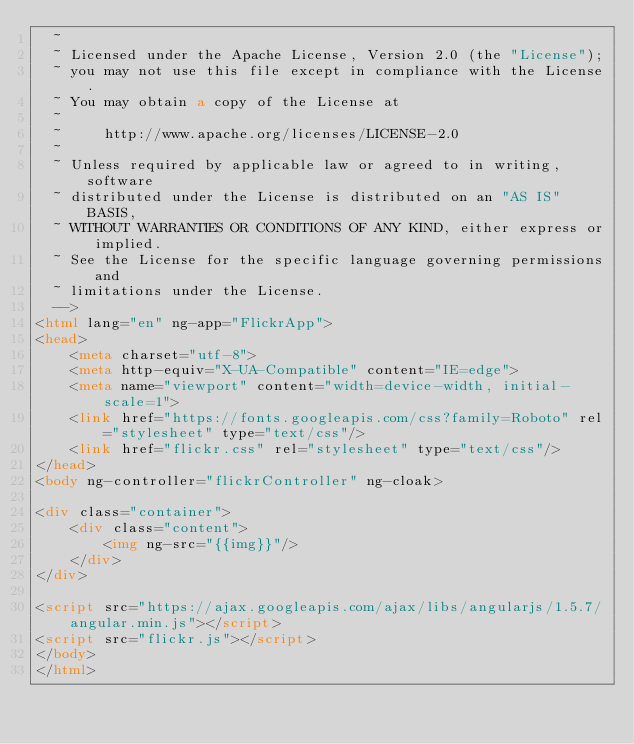Convert code to text. <code><loc_0><loc_0><loc_500><loc_500><_HTML_>  ~
  ~ Licensed under the Apache License, Version 2.0 (the "License");
  ~ you may not use this file except in compliance with the License.
  ~ You may obtain a copy of the License at
  ~
  ~     http://www.apache.org/licenses/LICENSE-2.0
  ~
  ~ Unless required by applicable law or agreed to in writing, software
  ~ distributed under the License is distributed on an "AS IS" BASIS,
  ~ WITHOUT WARRANTIES OR CONDITIONS OF ANY KIND, either express or implied.
  ~ See the License for the specific language governing permissions and
  ~ limitations under the License.
  -->
<html lang="en" ng-app="FlickrApp">
<head>
    <meta charset="utf-8">
    <meta http-equiv="X-UA-Compatible" content="IE=edge">
    <meta name="viewport" content="width=device-width, initial-scale=1">
    <link href="https://fonts.googleapis.com/css?family=Roboto" rel="stylesheet" type="text/css"/>
    <link href="flickr.css" rel="stylesheet" type="text/css"/>
</head>
<body ng-controller="flickrController" ng-cloak>

<div class="container">
    <div class="content">
        <img ng-src="{{img}}"/>
    </div>
</div>

<script src="https://ajax.googleapis.com/ajax/libs/angularjs/1.5.7/angular.min.js"></script>
<script src="flickr.js"></script>
</body>
</html></code> 